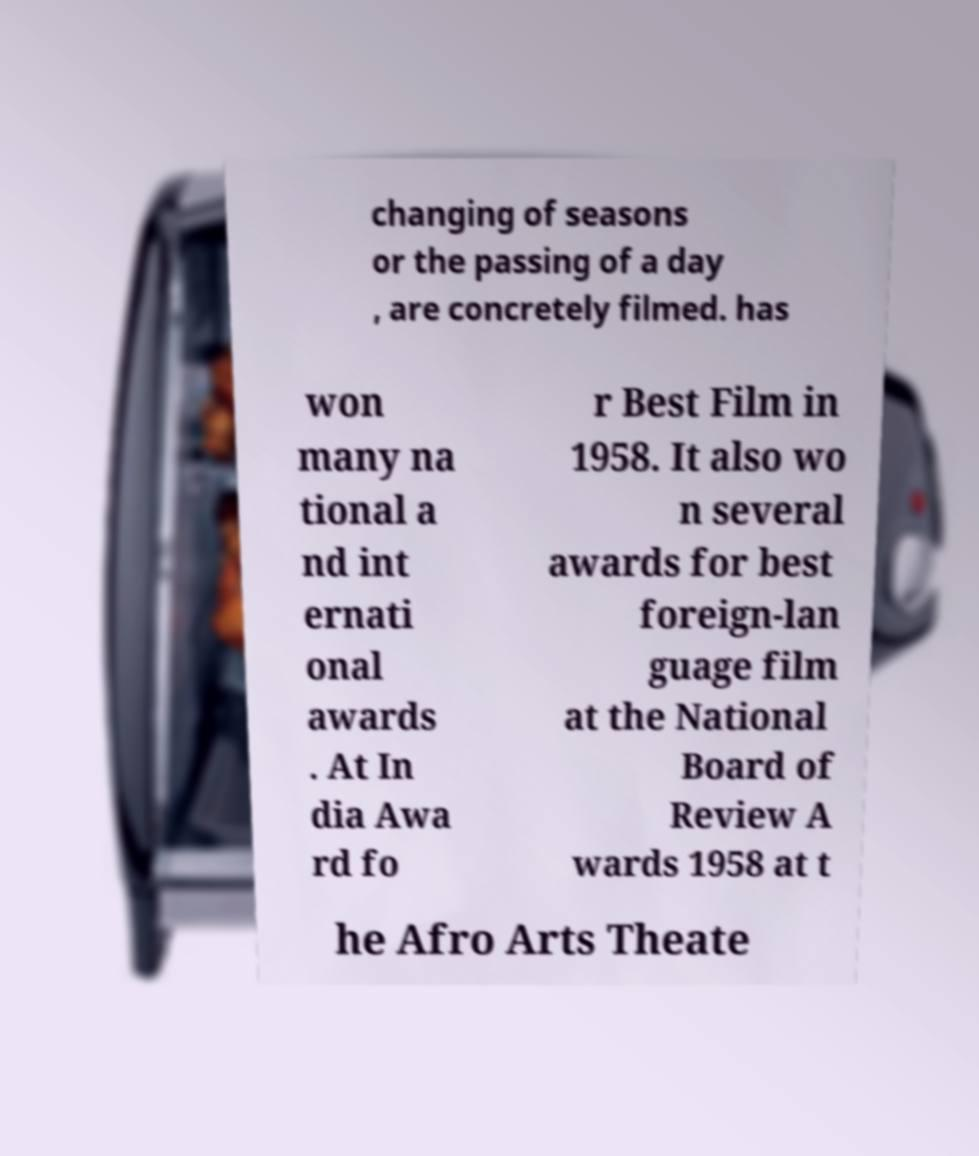What messages or text are displayed in this image? I need them in a readable, typed format. changing of seasons or the passing of a day , are concretely filmed. has won many na tional a nd int ernati onal awards . At In dia Awa rd fo r Best Film in 1958. It also wo n several awards for best foreign-lan guage film at the National Board of Review A wards 1958 at t he Afro Arts Theate 